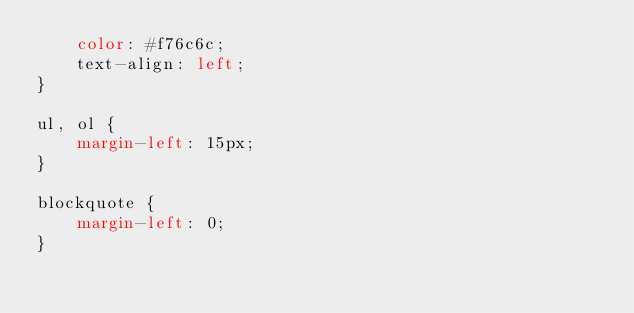<code> <loc_0><loc_0><loc_500><loc_500><_CSS_>    color: #f76c6c;
    text-align: left;
}

ul, ol {
    margin-left: 15px;
}

blockquote {
    margin-left: 0;
}</code> 